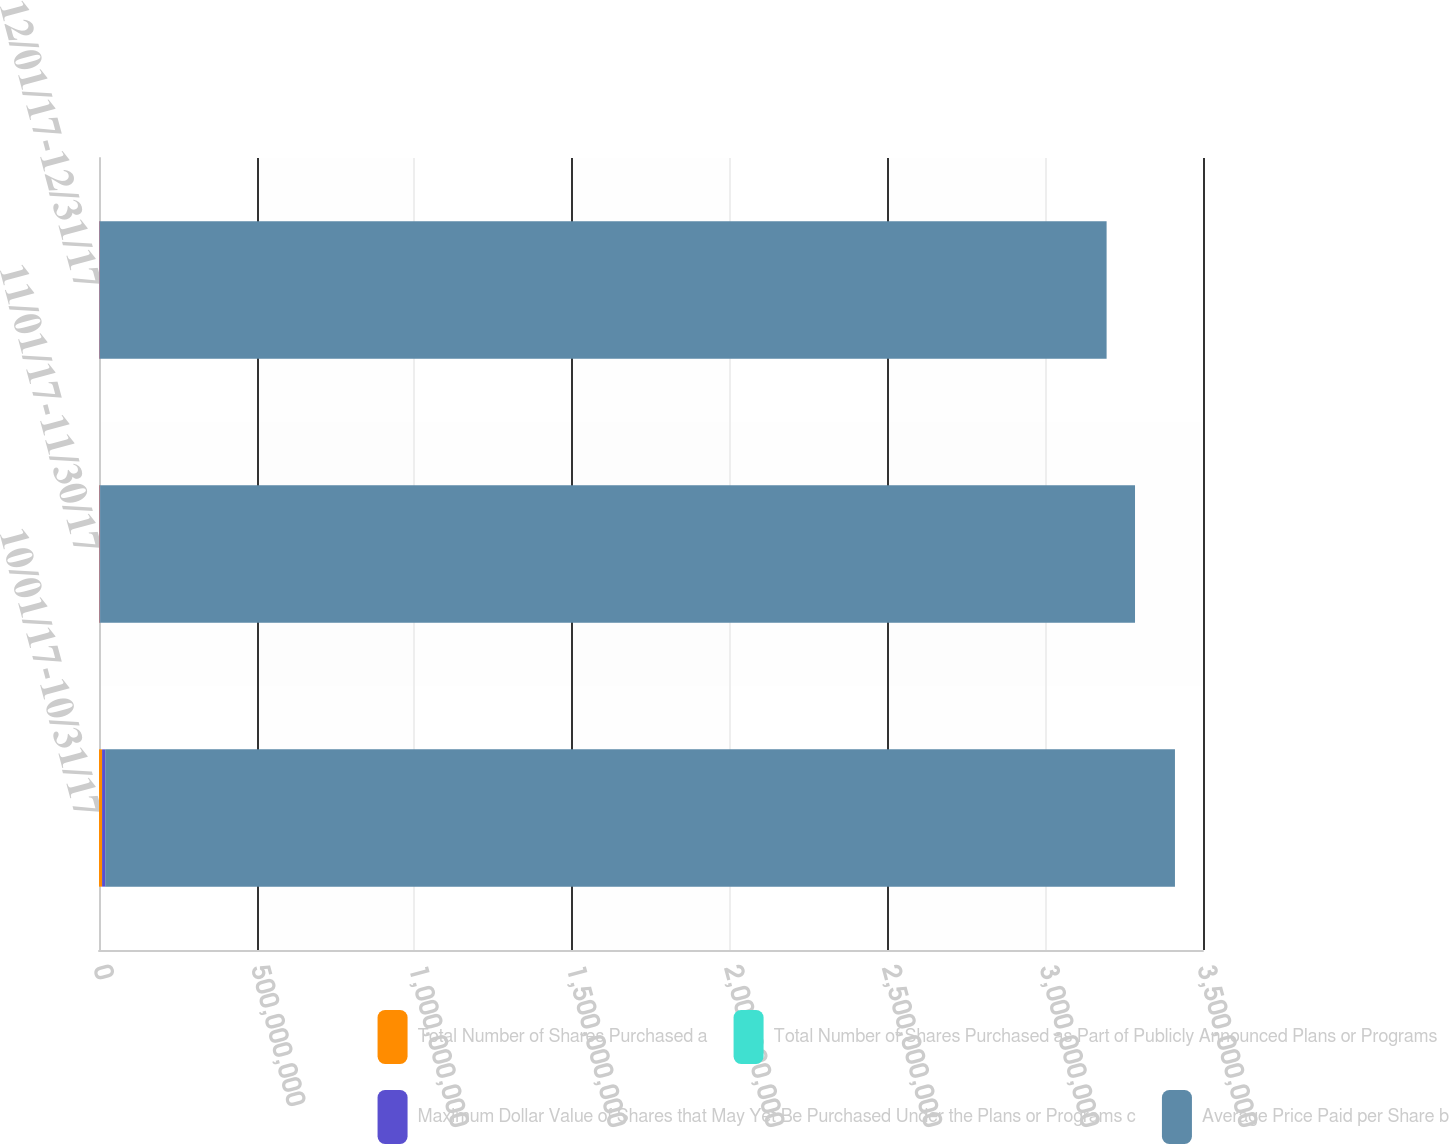<chart> <loc_0><loc_0><loc_500><loc_500><stacked_bar_chart><ecel><fcel>10/01/17-10/31/17<fcel>11/01/17-11/30/17<fcel>12/01/17-12/31/17<nl><fcel>Total Number of Shares Purchased a<fcel>9.75062e+06<fcel>1.78466e+06<fcel>1.42952e+06<nl><fcel>Total Number of Shares Purchased as Part of Publicly Announced Plans or Programs<fcel>56.43<fcel>62.03<fcel>62.78<nl><fcel>Maximum Dollar Value of Shares that May Yet Be Purchased Under the Plans or Programs c<fcel>9.74698e+06<fcel>1.78453e+06<fcel>1.42332e+06<nl><fcel>Average Price Paid per Share b<fcel>3.3916e+09<fcel>3.28091e+09<fcel>3.19155e+09<nl></chart> 